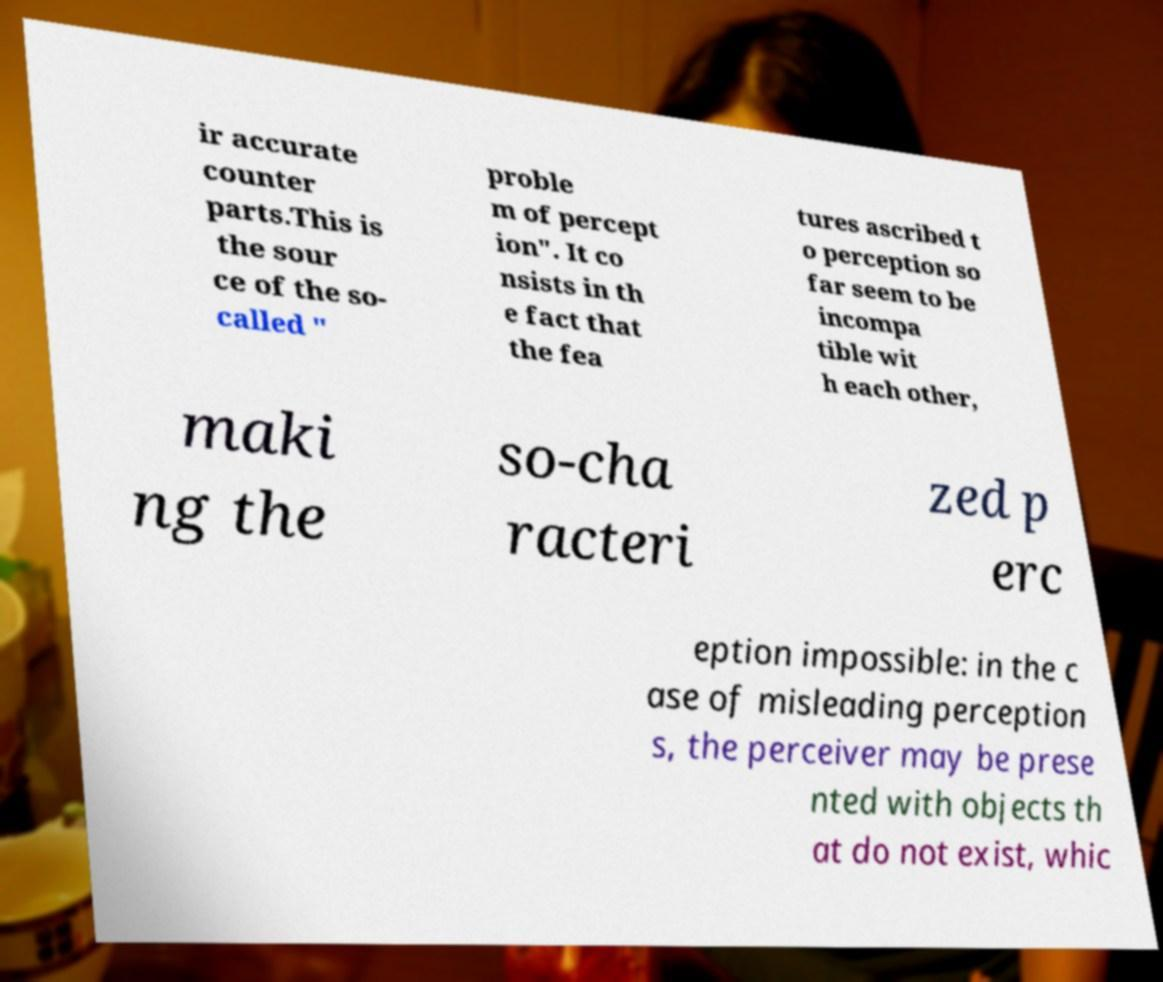Could you extract and type out the text from this image? ir accurate counter parts.This is the sour ce of the so- called " proble m of percept ion". It co nsists in th e fact that the fea tures ascribed t o perception so far seem to be incompa tible wit h each other, maki ng the so-cha racteri zed p erc eption impossible: in the c ase of misleading perception s, the perceiver may be prese nted with objects th at do not exist, whic 